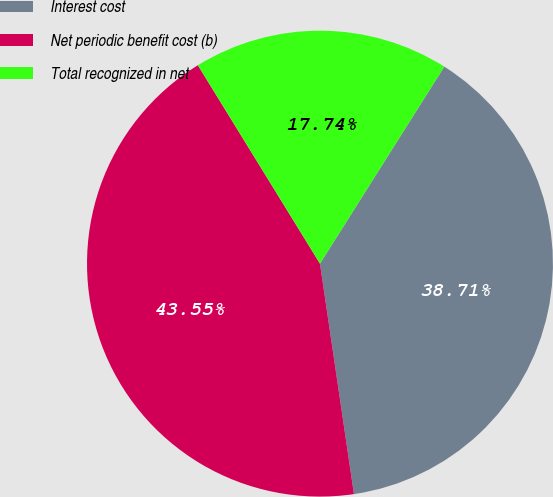Convert chart to OTSL. <chart><loc_0><loc_0><loc_500><loc_500><pie_chart><fcel>Interest cost<fcel>Net periodic benefit cost (b)<fcel>Total recognized in net<nl><fcel>38.71%<fcel>43.55%<fcel>17.74%<nl></chart> 